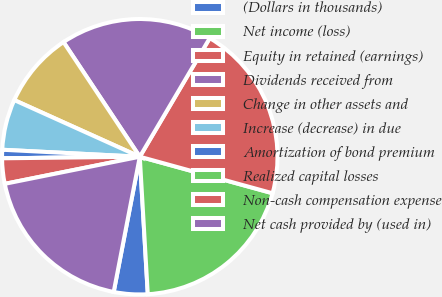Convert chart to OTSL. <chart><loc_0><loc_0><loc_500><loc_500><pie_chart><fcel>(Dollars in thousands)<fcel>Net income (loss)<fcel>Equity in retained (earnings)<fcel>Dividends received from<fcel>Change in other assets and<fcel>Increase (decrease) in due<fcel>Amortization of bond premium<fcel>Realized capital losses<fcel>Non-cash compensation expense<fcel>Net cash provided by (used in)<nl><fcel>3.96%<fcel>19.8%<fcel>20.79%<fcel>17.82%<fcel>8.91%<fcel>5.94%<fcel>0.99%<fcel>0.0%<fcel>2.97%<fcel>18.81%<nl></chart> 